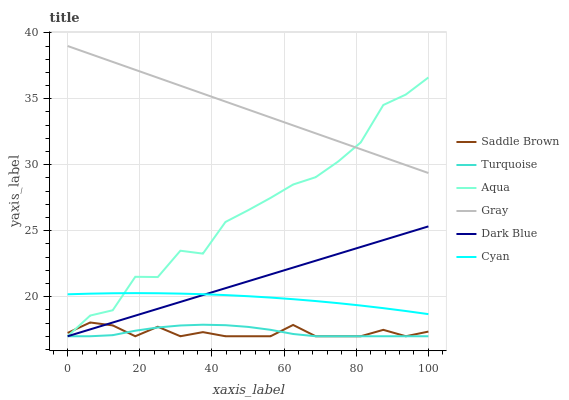Does Saddle Brown have the minimum area under the curve?
Answer yes or no. Yes. Does Gray have the maximum area under the curve?
Answer yes or no. Yes. Does Turquoise have the minimum area under the curve?
Answer yes or no. No. Does Turquoise have the maximum area under the curve?
Answer yes or no. No. Is Dark Blue the smoothest?
Answer yes or no. Yes. Is Aqua the roughest?
Answer yes or no. Yes. Is Turquoise the smoothest?
Answer yes or no. No. Is Turquoise the roughest?
Answer yes or no. No. Does Turquoise have the lowest value?
Answer yes or no. Yes. Does Cyan have the lowest value?
Answer yes or no. No. Does Gray have the highest value?
Answer yes or no. Yes. Does Aqua have the highest value?
Answer yes or no. No. Is Saddle Brown less than Gray?
Answer yes or no. Yes. Is Cyan greater than Turquoise?
Answer yes or no. Yes. Does Turquoise intersect Dark Blue?
Answer yes or no. Yes. Is Turquoise less than Dark Blue?
Answer yes or no. No. Is Turquoise greater than Dark Blue?
Answer yes or no. No. Does Saddle Brown intersect Gray?
Answer yes or no. No. 